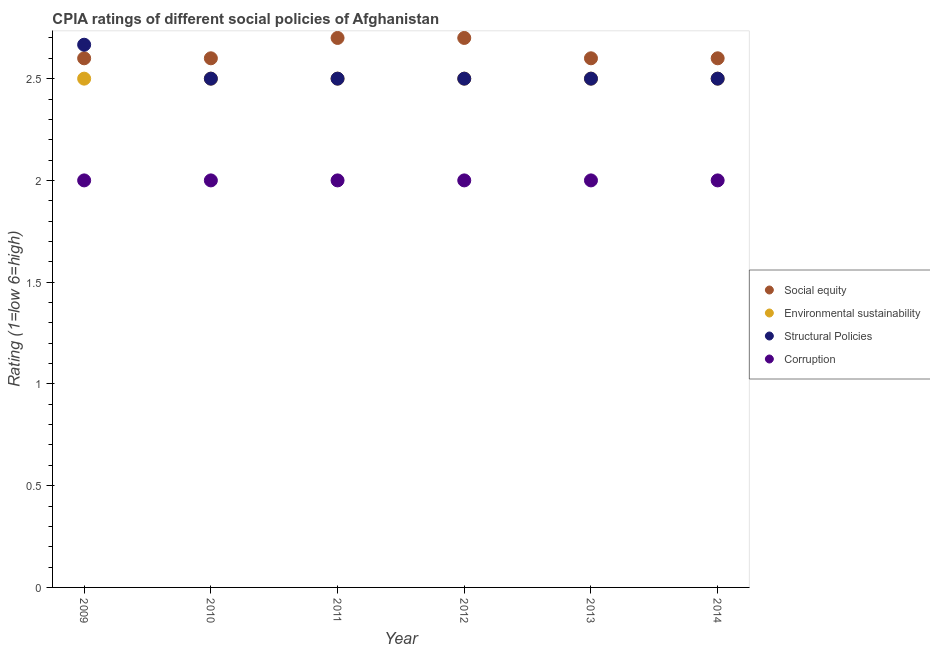How many different coloured dotlines are there?
Provide a succinct answer. 4. In which year was the cpia rating of environmental sustainability maximum?
Give a very brief answer. 2009. In which year was the cpia rating of structural policies minimum?
Offer a very short reply. 2010. What is the total cpia rating of environmental sustainability in the graph?
Give a very brief answer. 15. What is the difference between the cpia rating of structural policies in 2010 and that in 2013?
Your response must be concise. 0. What is the difference between the cpia rating of social equity in 2014 and the cpia rating of structural policies in 2009?
Your response must be concise. -0.07. What is the average cpia rating of social equity per year?
Your response must be concise. 2.63. In the year 2012, what is the difference between the cpia rating of structural policies and cpia rating of social equity?
Offer a very short reply. -0.2. In how many years, is the cpia rating of environmental sustainability greater than 1?
Provide a succinct answer. 6. Is the difference between the cpia rating of social equity in 2010 and 2014 greater than the difference between the cpia rating of environmental sustainability in 2010 and 2014?
Provide a succinct answer. No. What is the difference between the highest and the lowest cpia rating of structural policies?
Provide a short and direct response. 0.17. In how many years, is the cpia rating of corruption greater than the average cpia rating of corruption taken over all years?
Offer a terse response. 0. Is the cpia rating of corruption strictly greater than the cpia rating of social equity over the years?
Your answer should be compact. No. Does the graph contain any zero values?
Your answer should be compact. No. Where does the legend appear in the graph?
Keep it short and to the point. Center right. What is the title of the graph?
Your response must be concise. CPIA ratings of different social policies of Afghanistan. Does "Terrestrial protected areas" appear as one of the legend labels in the graph?
Keep it short and to the point. No. What is the label or title of the X-axis?
Keep it short and to the point. Year. What is the label or title of the Y-axis?
Offer a terse response. Rating (1=low 6=high). What is the Rating (1=low 6=high) of Environmental sustainability in 2009?
Your response must be concise. 2.5. What is the Rating (1=low 6=high) of Structural Policies in 2009?
Offer a terse response. 2.67. What is the Rating (1=low 6=high) in Corruption in 2009?
Keep it short and to the point. 2. What is the Rating (1=low 6=high) in Social equity in 2010?
Provide a succinct answer. 2.6. What is the Rating (1=low 6=high) of Structural Policies in 2010?
Provide a succinct answer. 2.5. What is the Rating (1=low 6=high) in Environmental sustainability in 2011?
Give a very brief answer. 2.5. What is the Rating (1=low 6=high) of Structural Policies in 2011?
Your answer should be compact. 2.5. What is the Rating (1=low 6=high) of Corruption in 2011?
Provide a short and direct response. 2. What is the Rating (1=low 6=high) in Environmental sustainability in 2012?
Ensure brevity in your answer.  2.5. What is the Rating (1=low 6=high) of Corruption in 2012?
Offer a very short reply. 2. What is the Rating (1=low 6=high) of Social equity in 2013?
Your answer should be very brief. 2.6. What is the Rating (1=low 6=high) of Environmental sustainability in 2013?
Offer a very short reply. 2.5. What is the Rating (1=low 6=high) of Corruption in 2014?
Keep it short and to the point. 2. Across all years, what is the maximum Rating (1=low 6=high) of Environmental sustainability?
Your answer should be compact. 2.5. Across all years, what is the maximum Rating (1=low 6=high) of Structural Policies?
Your answer should be very brief. 2.67. Across all years, what is the minimum Rating (1=low 6=high) of Social equity?
Make the answer very short. 2.6. What is the total Rating (1=low 6=high) of Social equity in the graph?
Your response must be concise. 15.8. What is the total Rating (1=low 6=high) in Structural Policies in the graph?
Keep it short and to the point. 15.17. What is the difference between the Rating (1=low 6=high) in Environmental sustainability in 2009 and that in 2010?
Give a very brief answer. 0. What is the difference between the Rating (1=low 6=high) of Corruption in 2009 and that in 2010?
Provide a succinct answer. 0. What is the difference between the Rating (1=low 6=high) in Environmental sustainability in 2009 and that in 2011?
Ensure brevity in your answer.  0. What is the difference between the Rating (1=low 6=high) of Corruption in 2009 and that in 2012?
Offer a terse response. 0. What is the difference between the Rating (1=low 6=high) in Social equity in 2009 and that in 2014?
Your answer should be compact. 0. What is the difference between the Rating (1=low 6=high) in Environmental sustainability in 2009 and that in 2014?
Your response must be concise. 0. What is the difference between the Rating (1=low 6=high) in Social equity in 2010 and that in 2011?
Offer a very short reply. -0.1. What is the difference between the Rating (1=low 6=high) in Environmental sustainability in 2010 and that in 2011?
Your response must be concise. 0. What is the difference between the Rating (1=low 6=high) in Environmental sustainability in 2010 and that in 2012?
Ensure brevity in your answer.  0. What is the difference between the Rating (1=low 6=high) of Corruption in 2010 and that in 2012?
Your response must be concise. 0. What is the difference between the Rating (1=low 6=high) of Social equity in 2010 and that in 2013?
Offer a very short reply. 0. What is the difference between the Rating (1=low 6=high) in Structural Policies in 2010 and that in 2013?
Your answer should be compact. 0. What is the difference between the Rating (1=low 6=high) of Corruption in 2010 and that in 2013?
Give a very brief answer. 0. What is the difference between the Rating (1=low 6=high) in Social equity in 2010 and that in 2014?
Your answer should be very brief. 0. What is the difference between the Rating (1=low 6=high) of Environmental sustainability in 2010 and that in 2014?
Your response must be concise. 0. What is the difference between the Rating (1=low 6=high) in Structural Policies in 2010 and that in 2014?
Keep it short and to the point. 0. What is the difference between the Rating (1=low 6=high) in Corruption in 2010 and that in 2014?
Make the answer very short. 0. What is the difference between the Rating (1=low 6=high) in Social equity in 2011 and that in 2012?
Offer a very short reply. 0. What is the difference between the Rating (1=low 6=high) in Environmental sustainability in 2011 and that in 2012?
Make the answer very short. 0. What is the difference between the Rating (1=low 6=high) in Corruption in 2011 and that in 2012?
Your response must be concise. 0. What is the difference between the Rating (1=low 6=high) of Environmental sustainability in 2011 and that in 2013?
Provide a short and direct response. 0. What is the difference between the Rating (1=low 6=high) in Environmental sustainability in 2011 and that in 2014?
Provide a short and direct response. 0. What is the difference between the Rating (1=low 6=high) in Structural Policies in 2011 and that in 2014?
Ensure brevity in your answer.  0. What is the difference between the Rating (1=low 6=high) in Social equity in 2012 and that in 2014?
Offer a terse response. 0.1. What is the difference between the Rating (1=low 6=high) of Environmental sustainability in 2012 and that in 2014?
Ensure brevity in your answer.  0. What is the difference between the Rating (1=low 6=high) of Structural Policies in 2012 and that in 2014?
Offer a very short reply. 0. What is the difference between the Rating (1=low 6=high) in Social equity in 2013 and that in 2014?
Provide a short and direct response. 0. What is the difference between the Rating (1=low 6=high) in Environmental sustainability in 2013 and that in 2014?
Make the answer very short. 0. What is the difference between the Rating (1=low 6=high) in Corruption in 2013 and that in 2014?
Provide a short and direct response. 0. What is the difference between the Rating (1=low 6=high) of Environmental sustainability in 2009 and the Rating (1=low 6=high) of Structural Policies in 2010?
Provide a short and direct response. 0. What is the difference between the Rating (1=low 6=high) of Social equity in 2009 and the Rating (1=low 6=high) of Environmental sustainability in 2011?
Offer a terse response. 0.1. What is the difference between the Rating (1=low 6=high) in Environmental sustainability in 2009 and the Rating (1=low 6=high) in Structural Policies in 2011?
Your answer should be compact. 0. What is the difference between the Rating (1=low 6=high) of Structural Policies in 2009 and the Rating (1=low 6=high) of Corruption in 2011?
Offer a very short reply. 0.67. What is the difference between the Rating (1=low 6=high) in Social equity in 2009 and the Rating (1=low 6=high) in Environmental sustainability in 2012?
Make the answer very short. 0.1. What is the difference between the Rating (1=low 6=high) of Social equity in 2009 and the Rating (1=low 6=high) of Corruption in 2012?
Your answer should be very brief. 0.6. What is the difference between the Rating (1=low 6=high) of Structural Policies in 2009 and the Rating (1=low 6=high) of Corruption in 2012?
Provide a succinct answer. 0.67. What is the difference between the Rating (1=low 6=high) of Social equity in 2009 and the Rating (1=low 6=high) of Environmental sustainability in 2013?
Provide a succinct answer. 0.1. What is the difference between the Rating (1=low 6=high) of Social equity in 2009 and the Rating (1=low 6=high) of Structural Policies in 2013?
Ensure brevity in your answer.  0.1. What is the difference between the Rating (1=low 6=high) of Social equity in 2009 and the Rating (1=low 6=high) of Corruption in 2013?
Provide a short and direct response. 0.6. What is the difference between the Rating (1=low 6=high) in Environmental sustainability in 2009 and the Rating (1=low 6=high) in Structural Policies in 2013?
Ensure brevity in your answer.  0. What is the difference between the Rating (1=low 6=high) in Environmental sustainability in 2009 and the Rating (1=low 6=high) in Corruption in 2013?
Your answer should be very brief. 0.5. What is the difference between the Rating (1=low 6=high) of Environmental sustainability in 2009 and the Rating (1=low 6=high) of Structural Policies in 2014?
Your answer should be very brief. 0. What is the difference between the Rating (1=low 6=high) of Social equity in 2010 and the Rating (1=low 6=high) of Environmental sustainability in 2011?
Offer a very short reply. 0.1. What is the difference between the Rating (1=low 6=high) of Social equity in 2010 and the Rating (1=low 6=high) of Structural Policies in 2012?
Offer a very short reply. 0.1. What is the difference between the Rating (1=low 6=high) of Social equity in 2010 and the Rating (1=low 6=high) of Corruption in 2012?
Offer a very short reply. 0.6. What is the difference between the Rating (1=low 6=high) in Environmental sustainability in 2010 and the Rating (1=low 6=high) in Structural Policies in 2012?
Ensure brevity in your answer.  0. What is the difference between the Rating (1=low 6=high) in Social equity in 2010 and the Rating (1=low 6=high) in Environmental sustainability in 2013?
Offer a terse response. 0.1. What is the difference between the Rating (1=low 6=high) of Environmental sustainability in 2010 and the Rating (1=low 6=high) of Structural Policies in 2013?
Ensure brevity in your answer.  0. What is the difference between the Rating (1=low 6=high) of Environmental sustainability in 2010 and the Rating (1=low 6=high) of Corruption in 2013?
Keep it short and to the point. 0.5. What is the difference between the Rating (1=low 6=high) in Social equity in 2011 and the Rating (1=low 6=high) in Environmental sustainability in 2012?
Your answer should be compact. 0.2. What is the difference between the Rating (1=low 6=high) in Social equity in 2011 and the Rating (1=low 6=high) in Corruption in 2012?
Your answer should be compact. 0.7. What is the difference between the Rating (1=low 6=high) of Environmental sustainability in 2011 and the Rating (1=low 6=high) of Corruption in 2012?
Provide a succinct answer. 0.5. What is the difference between the Rating (1=low 6=high) of Structural Policies in 2011 and the Rating (1=low 6=high) of Corruption in 2012?
Your response must be concise. 0.5. What is the difference between the Rating (1=low 6=high) of Social equity in 2011 and the Rating (1=low 6=high) of Corruption in 2013?
Provide a succinct answer. 0.7. What is the difference between the Rating (1=low 6=high) in Environmental sustainability in 2011 and the Rating (1=low 6=high) in Structural Policies in 2013?
Your response must be concise. 0. What is the difference between the Rating (1=low 6=high) in Environmental sustainability in 2011 and the Rating (1=low 6=high) in Corruption in 2013?
Keep it short and to the point. 0.5. What is the difference between the Rating (1=low 6=high) of Structural Policies in 2011 and the Rating (1=low 6=high) of Corruption in 2013?
Offer a very short reply. 0.5. What is the difference between the Rating (1=low 6=high) of Social equity in 2011 and the Rating (1=low 6=high) of Structural Policies in 2014?
Keep it short and to the point. 0.2. What is the difference between the Rating (1=low 6=high) in Environmental sustainability in 2011 and the Rating (1=low 6=high) in Structural Policies in 2014?
Your answer should be very brief. 0. What is the difference between the Rating (1=low 6=high) in Environmental sustainability in 2011 and the Rating (1=low 6=high) in Corruption in 2014?
Make the answer very short. 0.5. What is the difference between the Rating (1=low 6=high) in Social equity in 2012 and the Rating (1=low 6=high) in Environmental sustainability in 2013?
Keep it short and to the point. 0.2. What is the difference between the Rating (1=low 6=high) of Environmental sustainability in 2012 and the Rating (1=low 6=high) of Structural Policies in 2013?
Your response must be concise. 0. What is the difference between the Rating (1=low 6=high) in Environmental sustainability in 2012 and the Rating (1=low 6=high) in Corruption in 2013?
Make the answer very short. 0.5. What is the difference between the Rating (1=low 6=high) of Social equity in 2012 and the Rating (1=low 6=high) of Environmental sustainability in 2014?
Give a very brief answer. 0.2. What is the difference between the Rating (1=low 6=high) of Social equity in 2012 and the Rating (1=low 6=high) of Corruption in 2014?
Your response must be concise. 0.7. What is the difference between the Rating (1=low 6=high) in Environmental sustainability in 2012 and the Rating (1=low 6=high) in Structural Policies in 2014?
Your answer should be compact. 0. What is the difference between the Rating (1=low 6=high) of Structural Policies in 2012 and the Rating (1=low 6=high) of Corruption in 2014?
Offer a terse response. 0.5. What is the difference between the Rating (1=low 6=high) in Social equity in 2013 and the Rating (1=low 6=high) in Environmental sustainability in 2014?
Provide a succinct answer. 0.1. What is the difference between the Rating (1=low 6=high) of Social equity in 2013 and the Rating (1=low 6=high) of Structural Policies in 2014?
Give a very brief answer. 0.1. What is the difference between the Rating (1=low 6=high) in Environmental sustainability in 2013 and the Rating (1=low 6=high) in Structural Policies in 2014?
Offer a very short reply. 0. What is the difference between the Rating (1=low 6=high) of Environmental sustainability in 2013 and the Rating (1=low 6=high) of Corruption in 2014?
Your response must be concise. 0.5. What is the difference between the Rating (1=low 6=high) in Structural Policies in 2013 and the Rating (1=low 6=high) in Corruption in 2014?
Your answer should be very brief. 0.5. What is the average Rating (1=low 6=high) of Social equity per year?
Make the answer very short. 2.63. What is the average Rating (1=low 6=high) in Environmental sustainability per year?
Provide a succinct answer. 2.5. What is the average Rating (1=low 6=high) of Structural Policies per year?
Keep it short and to the point. 2.53. What is the average Rating (1=low 6=high) of Corruption per year?
Provide a short and direct response. 2. In the year 2009, what is the difference between the Rating (1=low 6=high) in Social equity and Rating (1=low 6=high) in Structural Policies?
Give a very brief answer. -0.07. In the year 2009, what is the difference between the Rating (1=low 6=high) of Environmental sustainability and Rating (1=low 6=high) of Corruption?
Offer a very short reply. 0.5. In the year 2009, what is the difference between the Rating (1=low 6=high) of Structural Policies and Rating (1=low 6=high) of Corruption?
Make the answer very short. 0.67. In the year 2010, what is the difference between the Rating (1=low 6=high) of Social equity and Rating (1=low 6=high) of Corruption?
Provide a succinct answer. 0.6. In the year 2010, what is the difference between the Rating (1=low 6=high) in Environmental sustainability and Rating (1=low 6=high) in Structural Policies?
Your response must be concise. 0. In the year 2010, what is the difference between the Rating (1=low 6=high) of Environmental sustainability and Rating (1=low 6=high) of Corruption?
Your response must be concise. 0.5. In the year 2010, what is the difference between the Rating (1=low 6=high) in Structural Policies and Rating (1=low 6=high) in Corruption?
Your answer should be compact. 0.5. In the year 2011, what is the difference between the Rating (1=low 6=high) of Social equity and Rating (1=low 6=high) of Environmental sustainability?
Your answer should be compact. 0.2. In the year 2012, what is the difference between the Rating (1=low 6=high) in Environmental sustainability and Rating (1=low 6=high) in Corruption?
Give a very brief answer. 0.5. In the year 2012, what is the difference between the Rating (1=low 6=high) of Structural Policies and Rating (1=low 6=high) of Corruption?
Your response must be concise. 0.5. In the year 2013, what is the difference between the Rating (1=low 6=high) in Social equity and Rating (1=low 6=high) in Environmental sustainability?
Keep it short and to the point. 0.1. In the year 2013, what is the difference between the Rating (1=low 6=high) in Social equity and Rating (1=low 6=high) in Structural Policies?
Ensure brevity in your answer.  0.1. In the year 2013, what is the difference between the Rating (1=low 6=high) in Social equity and Rating (1=low 6=high) in Corruption?
Offer a very short reply. 0.6. In the year 2013, what is the difference between the Rating (1=low 6=high) of Environmental sustainability and Rating (1=low 6=high) of Corruption?
Make the answer very short. 0.5. In the year 2014, what is the difference between the Rating (1=low 6=high) in Social equity and Rating (1=low 6=high) in Corruption?
Provide a short and direct response. 0.6. In the year 2014, what is the difference between the Rating (1=low 6=high) of Structural Policies and Rating (1=low 6=high) of Corruption?
Provide a short and direct response. 0.5. What is the ratio of the Rating (1=low 6=high) of Social equity in 2009 to that in 2010?
Your response must be concise. 1. What is the ratio of the Rating (1=low 6=high) in Structural Policies in 2009 to that in 2010?
Make the answer very short. 1.07. What is the ratio of the Rating (1=low 6=high) in Environmental sustainability in 2009 to that in 2011?
Offer a very short reply. 1. What is the ratio of the Rating (1=low 6=high) in Structural Policies in 2009 to that in 2011?
Your response must be concise. 1.07. What is the ratio of the Rating (1=low 6=high) in Corruption in 2009 to that in 2011?
Ensure brevity in your answer.  1. What is the ratio of the Rating (1=low 6=high) in Social equity in 2009 to that in 2012?
Keep it short and to the point. 0.96. What is the ratio of the Rating (1=low 6=high) of Structural Policies in 2009 to that in 2012?
Your response must be concise. 1.07. What is the ratio of the Rating (1=low 6=high) of Social equity in 2009 to that in 2013?
Your answer should be compact. 1. What is the ratio of the Rating (1=low 6=high) of Structural Policies in 2009 to that in 2013?
Keep it short and to the point. 1.07. What is the ratio of the Rating (1=low 6=high) in Corruption in 2009 to that in 2013?
Ensure brevity in your answer.  1. What is the ratio of the Rating (1=low 6=high) in Structural Policies in 2009 to that in 2014?
Provide a short and direct response. 1.07. What is the ratio of the Rating (1=low 6=high) of Social equity in 2010 to that in 2011?
Your answer should be very brief. 0.96. What is the ratio of the Rating (1=low 6=high) of Structural Policies in 2010 to that in 2011?
Provide a succinct answer. 1. What is the ratio of the Rating (1=low 6=high) in Social equity in 2010 to that in 2012?
Offer a very short reply. 0.96. What is the ratio of the Rating (1=low 6=high) of Environmental sustainability in 2010 to that in 2012?
Give a very brief answer. 1. What is the ratio of the Rating (1=low 6=high) in Environmental sustainability in 2010 to that in 2013?
Your response must be concise. 1. What is the ratio of the Rating (1=low 6=high) of Corruption in 2010 to that in 2013?
Give a very brief answer. 1. What is the ratio of the Rating (1=low 6=high) of Social equity in 2010 to that in 2014?
Offer a terse response. 1. What is the ratio of the Rating (1=low 6=high) in Environmental sustainability in 2010 to that in 2014?
Make the answer very short. 1. What is the ratio of the Rating (1=low 6=high) of Structural Policies in 2010 to that in 2014?
Your response must be concise. 1. What is the ratio of the Rating (1=low 6=high) of Corruption in 2010 to that in 2014?
Ensure brevity in your answer.  1. What is the ratio of the Rating (1=low 6=high) in Environmental sustainability in 2011 to that in 2012?
Make the answer very short. 1. What is the ratio of the Rating (1=low 6=high) of Structural Policies in 2011 to that in 2012?
Offer a very short reply. 1. What is the ratio of the Rating (1=low 6=high) of Corruption in 2011 to that in 2012?
Make the answer very short. 1. What is the ratio of the Rating (1=low 6=high) of Social equity in 2011 to that in 2013?
Make the answer very short. 1.04. What is the ratio of the Rating (1=low 6=high) in Environmental sustainability in 2011 to that in 2013?
Offer a very short reply. 1. What is the ratio of the Rating (1=low 6=high) of Structural Policies in 2011 to that in 2013?
Your answer should be compact. 1. What is the ratio of the Rating (1=low 6=high) of Corruption in 2011 to that in 2013?
Make the answer very short. 1. What is the ratio of the Rating (1=low 6=high) of Environmental sustainability in 2011 to that in 2014?
Your answer should be compact. 1. What is the ratio of the Rating (1=low 6=high) in Structural Policies in 2011 to that in 2014?
Provide a succinct answer. 1. What is the ratio of the Rating (1=low 6=high) of Corruption in 2011 to that in 2014?
Ensure brevity in your answer.  1. What is the ratio of the Rating (1=low 6=high) of Social equity in 2012 to that in 2013?
Offer a very short reply. 1.04. What is the ratio of the Rating (1=low 6=high) in Environmental sustainability in 2012 to that in 2013?
Make the answer very short. 1. What is the ratio of the Rating (1=low 6=high) of Structural Policies in 2012 to that in 2013?
Ensure brevity in your answer.  1. What is the ratio of the Rating (1=low 6=high) in Social equity in 2012 to that in 2014?
Provide a succinct answer. 1.04. What is the ratio of the Rating (1=low 6=high) in Environmental sustainability in 2012 to that in 2014?
Keep it short and to the point. 1. What is the ratio of the Rating (1=low 6=high) of Corruption in 2012 to that in 2014?
Give a very brief answer. 1. What is the ratio of the Rating (1=low 6=high) in Social equity in 2013 to that in 2014?
Your answer should be compact. 1. What is the ratio of the Rating (1=low 6=high) of Structural Policies in 2013 to that in 2014?
Offer a very short reply. 1. What is the difference between the highest and the second highest Rating (1=low 6=high) of Social equity?
Your response must be concise. 0. What is the difference between the highest and the second highest Rating (1=low 6=high) in Environmental sustainability?
Your answer should be very brief. 0. What is the difference between the highest and the second highest Rating (1=low 6=high) in Structural Policies?
Provide a succinct answer. 0.17. What is the difference between the highest and the second highest Rating (1=low 6=high) of Corruption?
Keep it short and to the point. 0. What is the difference between the highest and the lowest Rating (1=low 6=high) of Social equity?
Your response must be concise. 0.1. 